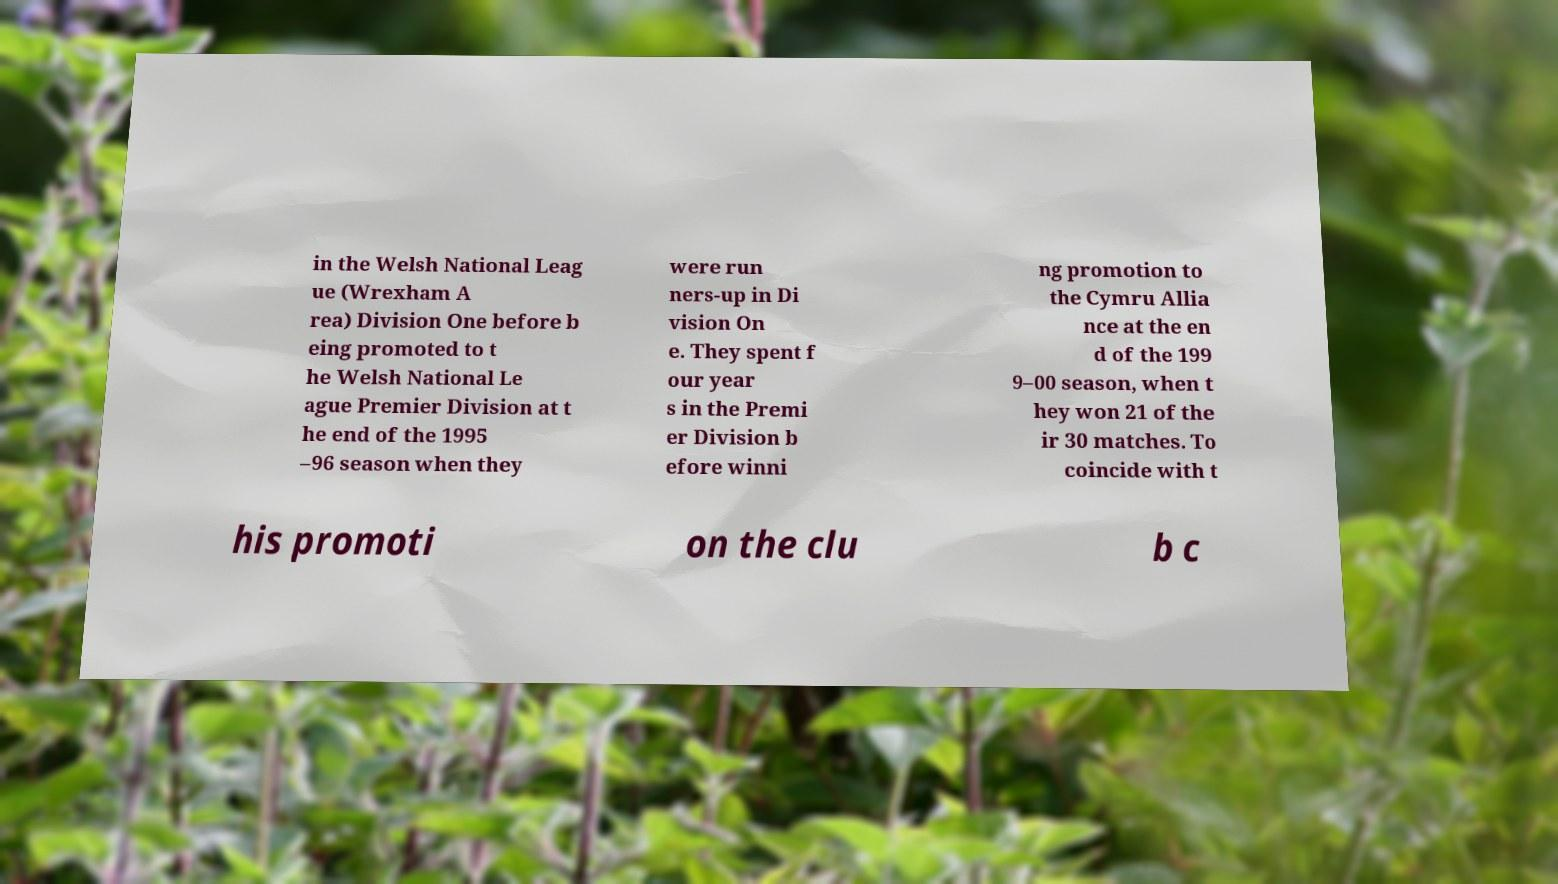For documentation purposes, I need the text within this image transcribed. Could you provide that? in the Welsh National Leag ue (Wrexham A rea) Division One before b eing promoted to t he Welsh National Le ague Premier Division at t he end of the 1995 –96 season when they were run ners-up in Di vision On e. They spent f our year s in the Premi er Division b efore winni ng promotion to the Cymru Allia nce at the en d of the 199 9–00 season, when t hey won 21 of the ir 30 matches. To coincide with t his promoti on the clu b c 